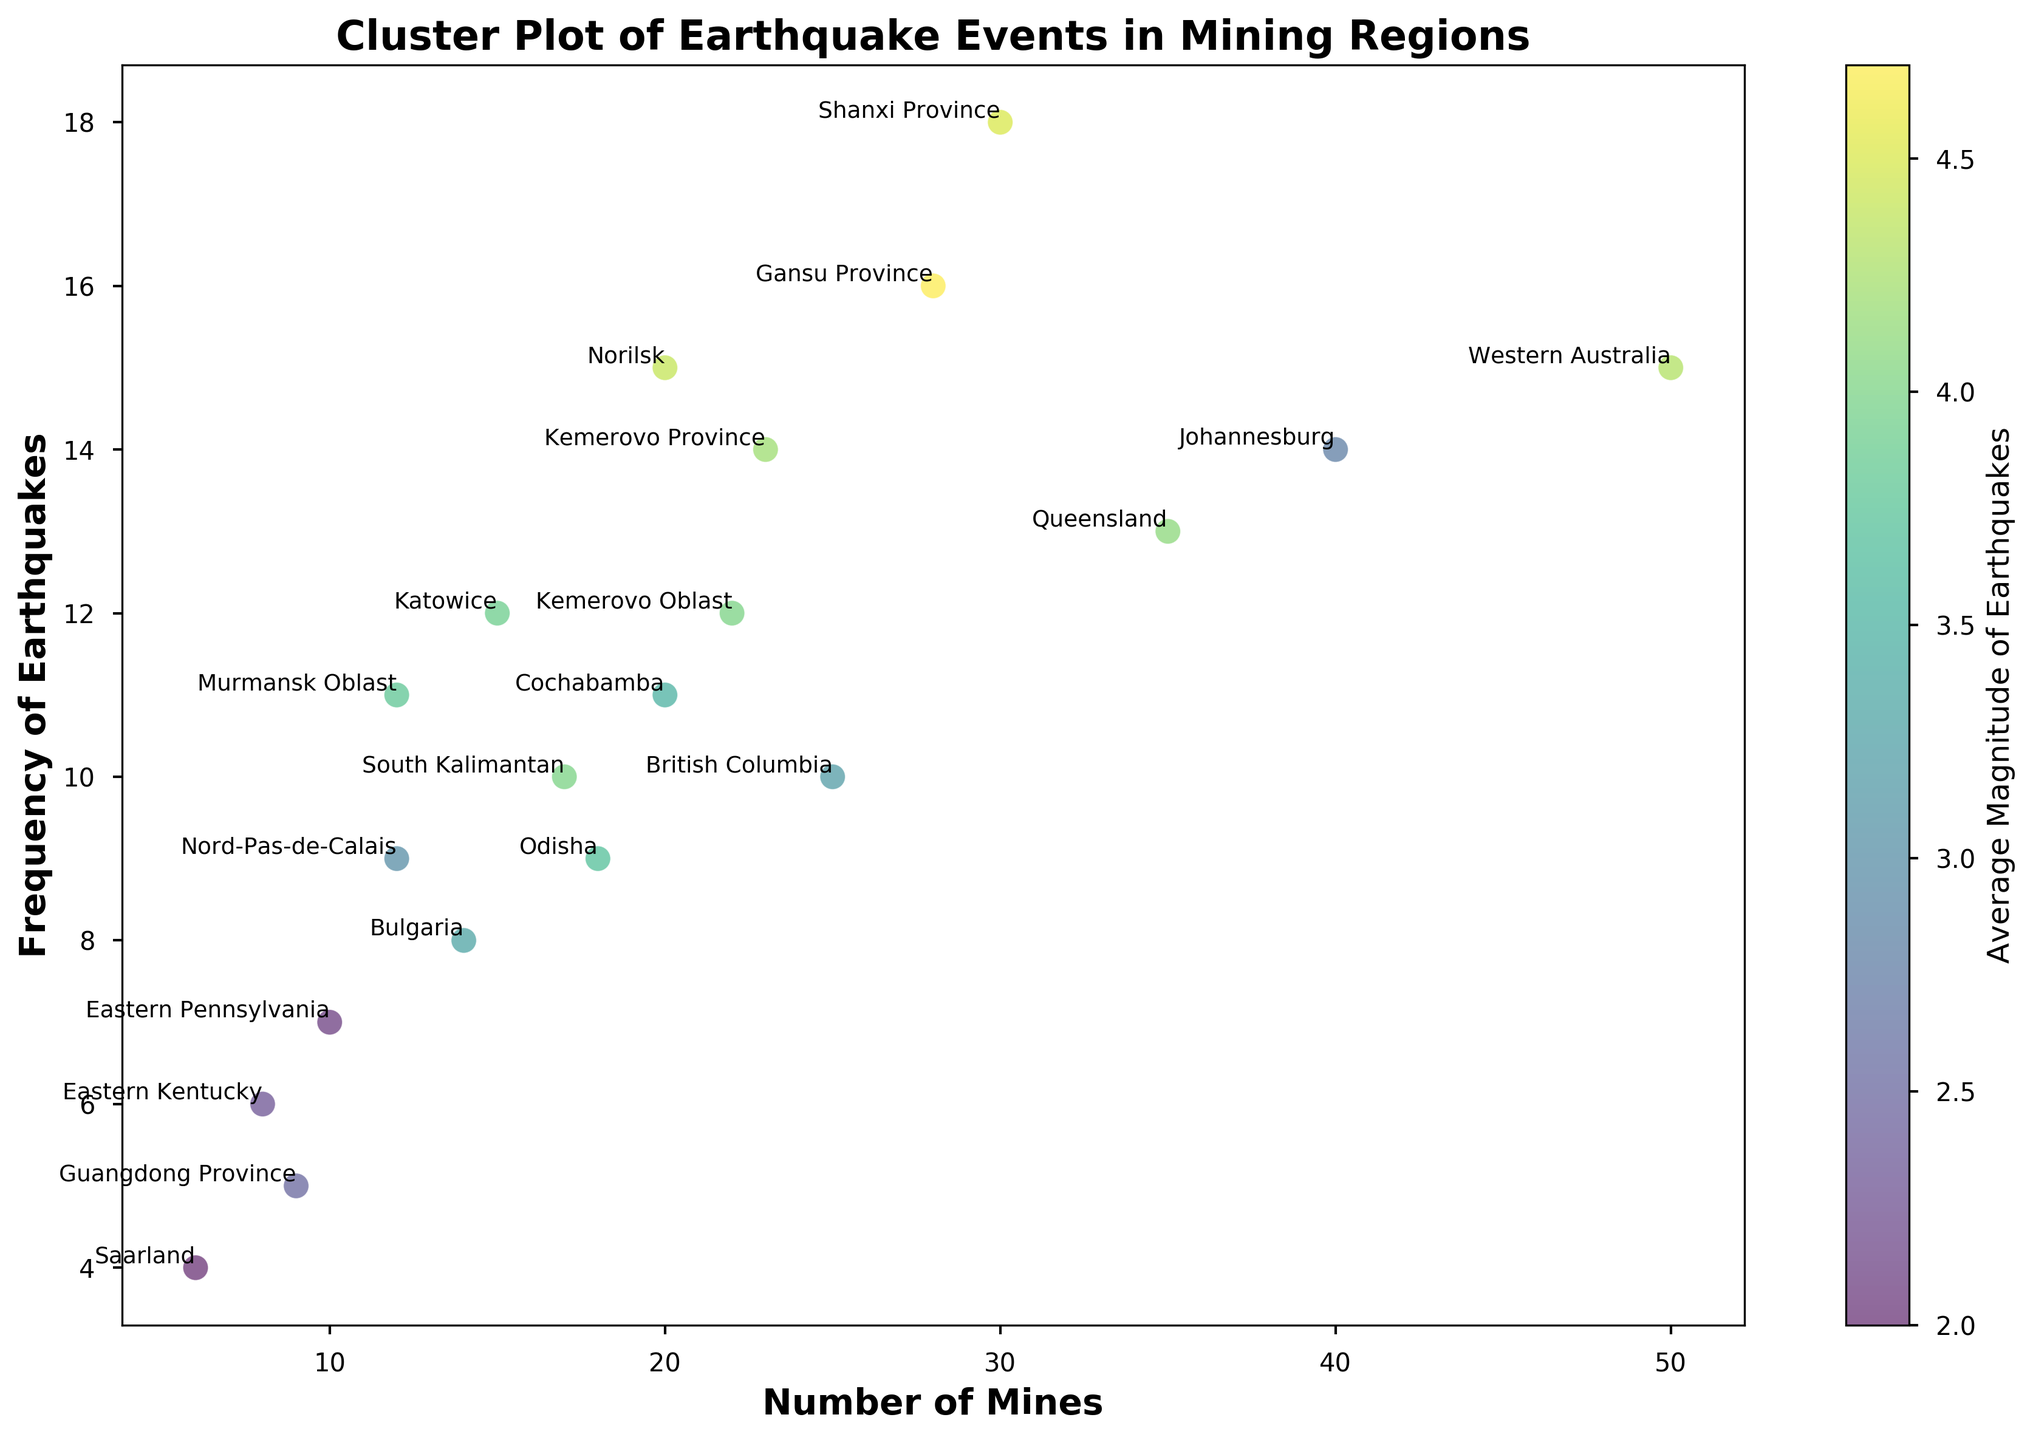Which region has the highest frequency of earthquakes? By analyzing the y-axis values, we can identify the region plotted highest on the y-axis, which represents the frequency of earthquakes. In this case, it is Shanxi Province at a frequency of 18.
Answer: Shanxi Province Which region has the highest average magnitude of earthquakes? The color bar indicates the average magnitude of earthquakes. The region associated with the darkest shade represents the highest average magnitude of earthquakes. Gansu Province shows the highest magnitude with 4.7.
Answer: Gansu Province Which region has the least number of mines but a relatively high frequency of earthquakes? To find this, look for the point farthest left on the x-axis (fewer mines) that is relatively high on the y-axis (higher frequency). Eastern Pennsylvania, with 10 mines and a frequency of 7, fits this description.
Answer: Eastern Pennsylvania What is the average number of mines across all regions in the plot? Sum the number of mines for all regions and divide by the number of regions: (50 + 10 + 12 + 15 + 30 + 25 + 28 + 20 + 40 + 35 + 18 + 6 + 22 + 14 + 9 + 8 + 17 + 23 + 12 + 20) / 20 = 22.6.
Answer: 22.6 Which region has the highest frequency of earthquakes among those with an average magnitude less than 3.0? Identify the regions with an average magnitude less than 3.0 (using the color bar to visually estimate lighter shades). Johannesburg and Saarland meet this criteria, with Johannesburg having a higher frequency of 14.
Answer: Johannesburg Between Odisha and Katowice, which has a higher average magnitude of earthquakes? Check the color of the points for Odisha and Katowice and refer to the color bar. Katowice, coded darker, has a higher average magnitude at 3.9 compared to Odisha’s 3.7.
Answer: Katowice How do the frequency of earthquakes and the average magnitude relate in Western Australia compared to Norilsk? Western Australia and Norilsk both have significant frequencies (15 for both), but Western Australia's average magnitude is lesser than Norilsk's (4.3 vs 4.4 as seen via the color bar).
Answer: Norilsk has a slightly higher average magnitude Among the regions with 20 or more mines, which one has the lowest frequency of earthquakes? Filter out regions with 20 or more mines and then find the lowest point on the y-axis among them: Queensland (frequency of 13) has 35 mines, making it the lowest among large mining regions.
Answer: Queensland What is the sum of the frequencies of earthquakes in regions with an average magnitude of earthquakes greater than 4.0? Sum the frequencies for regions with average magnitudes greater than 4.0 from the color bar: (Shanxi Province 18 + Gansu Province 16 + Western Australia 15 + Norilsk 15 + Kemerovo Province 14 + Queensland 13) = 91.
Answer: 91 Comparing Gansu Province and Guangdong Province, which has a higher average magnitude and how much higher? From the color bar, Gansu Province has a magnitude of 4.7, and Guangdong Province has 2.5. The difference is 4.7 - 2.5 = 2.2.
Answer: Gansu Province has 2.2 higher magnitude 